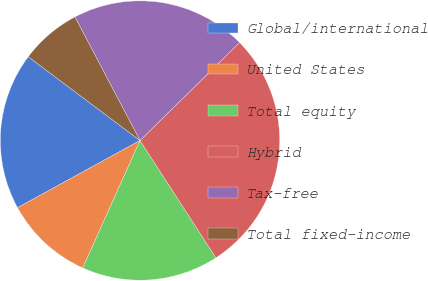Convert chart to OTSL. <chart><loc_0><loc_0><loc_500><loc_500><pie_chart><fcel>Global/international<fcel>United States<fcel>Total equity<fcel>Hybrid<fcel>Tax-free<fcel>Total fixed-income<nl><fcel>18.22%<fcel>10.29%<fcel>15.87%<fcel>28.22%<fcel>20.34%<fcel>7.05%<nl></chart> 